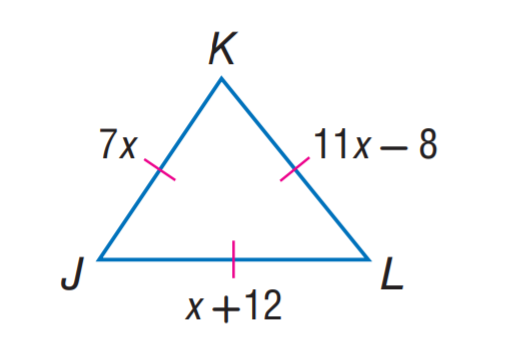Answer the mathemtical geometry problem and directly provide the correct option letter.
Question: Find J K.
Choices: A: 7 B: 11 C: 12 D: 14 D 